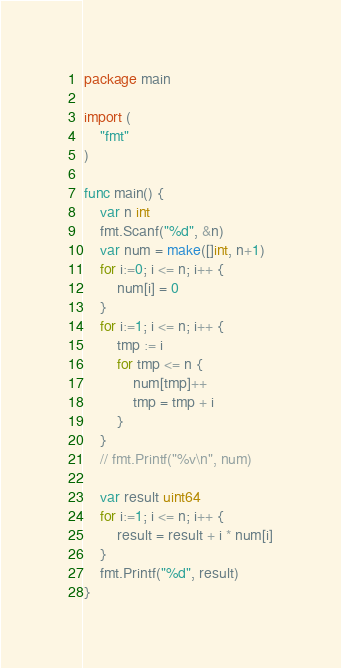Convert code to text. <code><loc_0><loc_0><loc_500><loc_500><_Go_>package main

import (
	"fmt"
)

func main() {
	var n int
	fmt.Scanf("%d", &n)
	var num = make([]int, n+1)
	for i:=0; i <= n; i++ {
		num[i] = 0
	}
	for i:=1; i <= n; i++ {
		tmp := i
		for tmp <= n {
			num[tmp]++
			tmp = tmp + i
		}
	}
	// fmt.Printf("%v\n", num)

	var result uint64
	for i:=1; i <= n; i++ {
		result = result + i * num[i]
	}
	fmt.Printf("%d", result)
}
</code> 